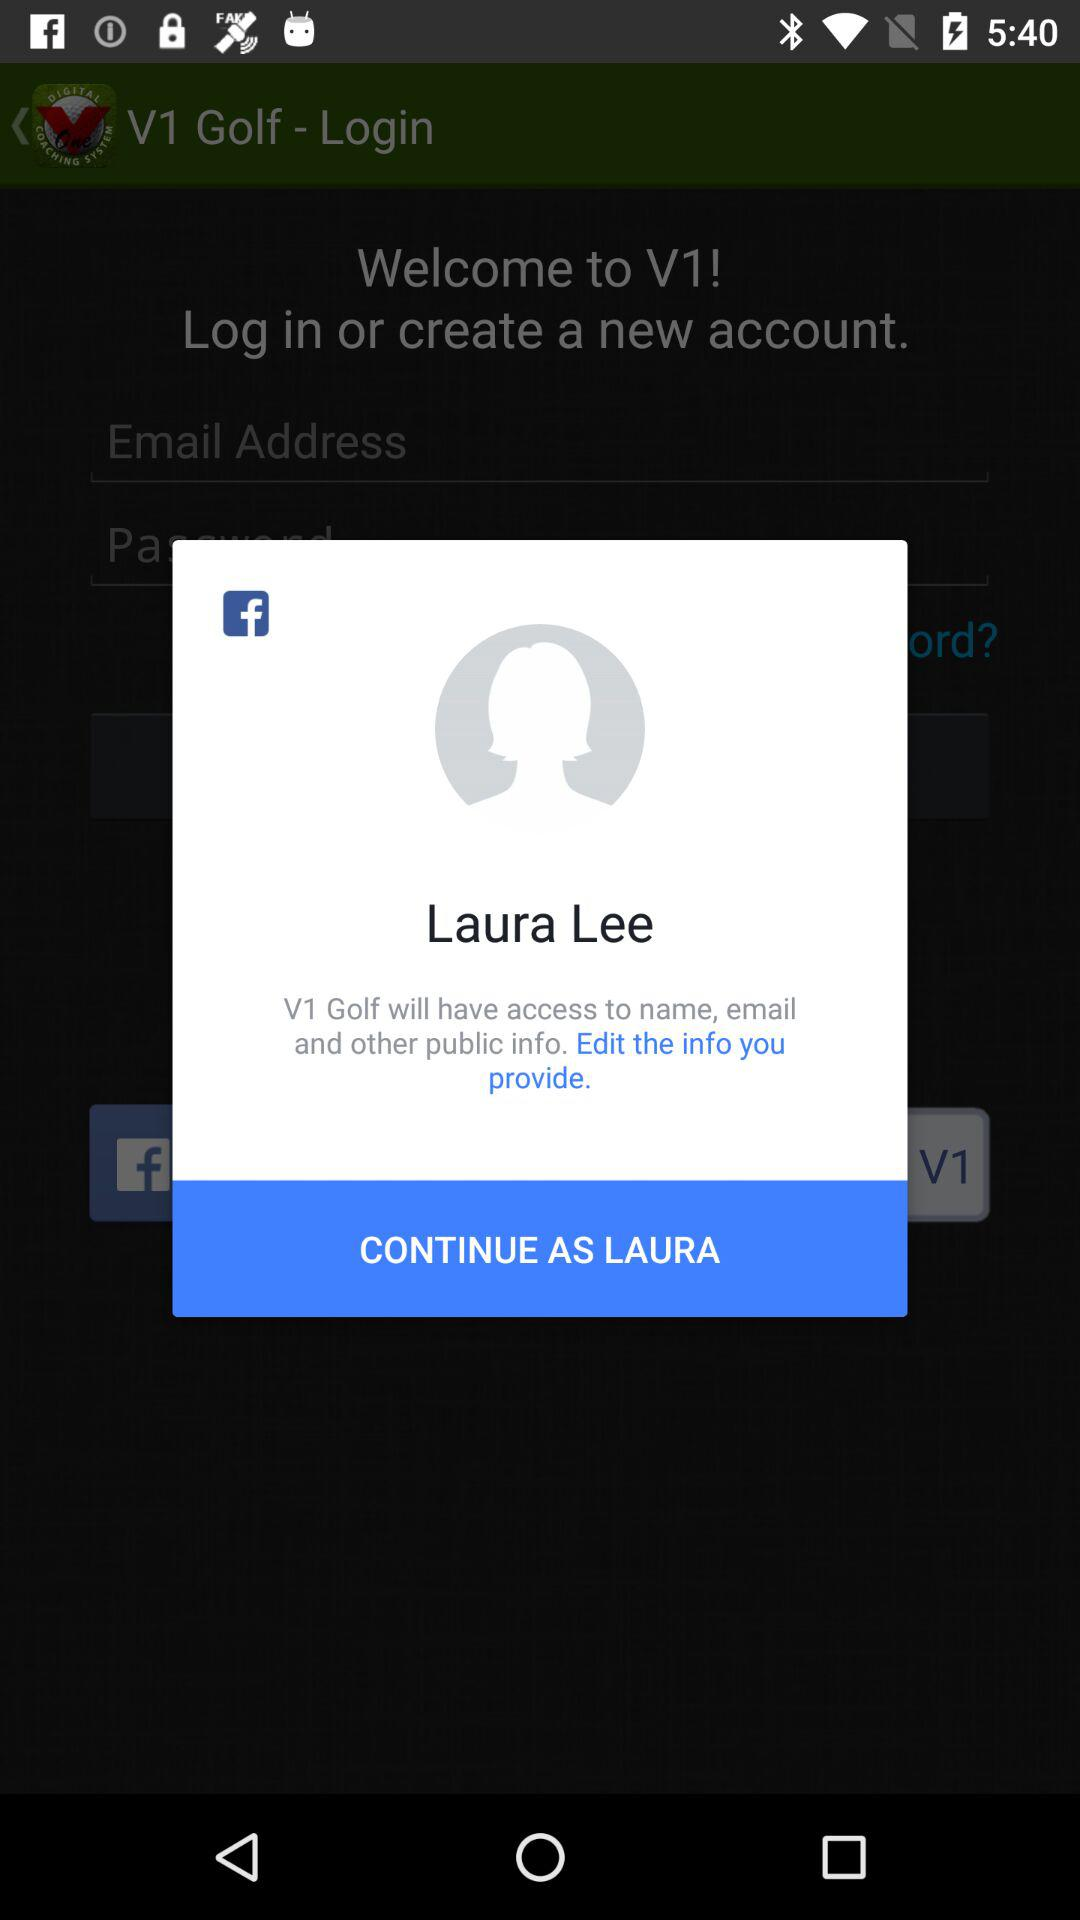What is the user's name? The user's name is Laura Lee. 